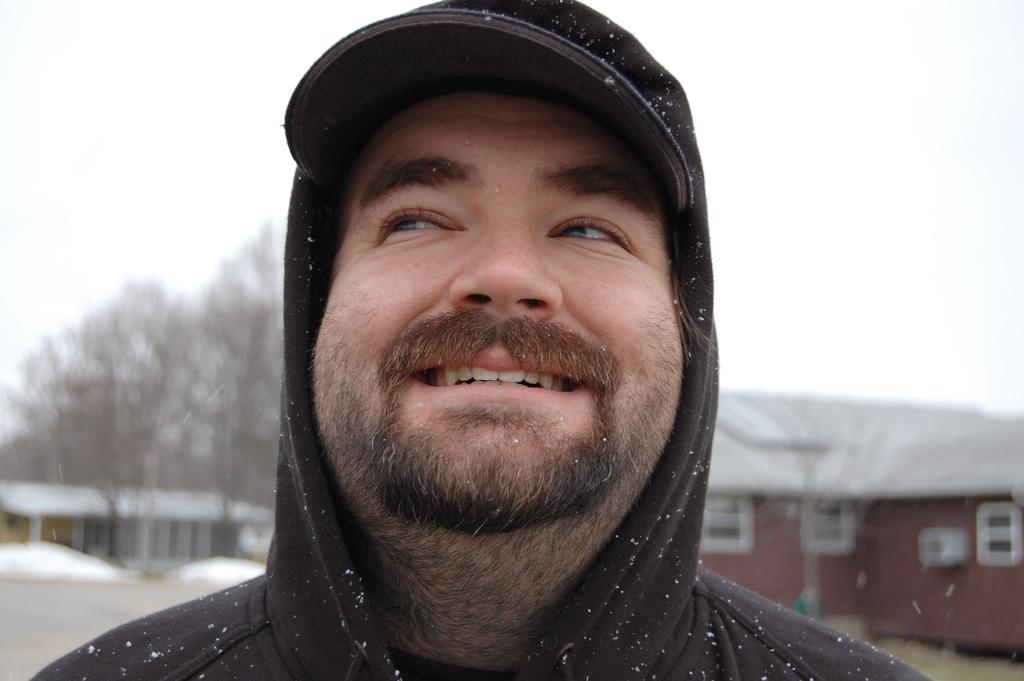Who is the main subject in the image? There is a man in the middle of the image. What is the man wearing on his head? The man is wearing a cap. What is the man's facial expression? The man is smiling. What can be seen behind the man? There are buildings visible behind the man. What type of vegetation is present in the background? Trees are present in the background. What weather condition is depicted in the image? Snow is visible in the image. What year is the carriage depicted in the image? There is no carriage present in the image. What type of toothbrush is the man using in the image? There is no toothbrush present in the image. 